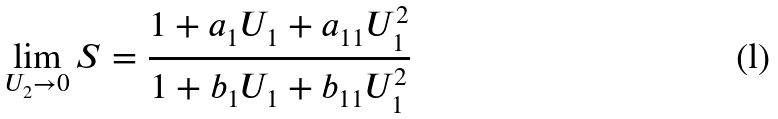Convert formula to latex. <formula><loc_0><loc_0><loc_500><loc_500>\lim _ { U _ { 2 } \to 0 } S = \frac { 1 + a _ { 1 } U _ { 1 } + a _ { 1 1 } U _ { 1 } ^ { 2 } } { 1 + b _ { 1 } U _ { 1 } + b _ { 1 1 } U _ { 1 } ^ { 2 } }</formula> 